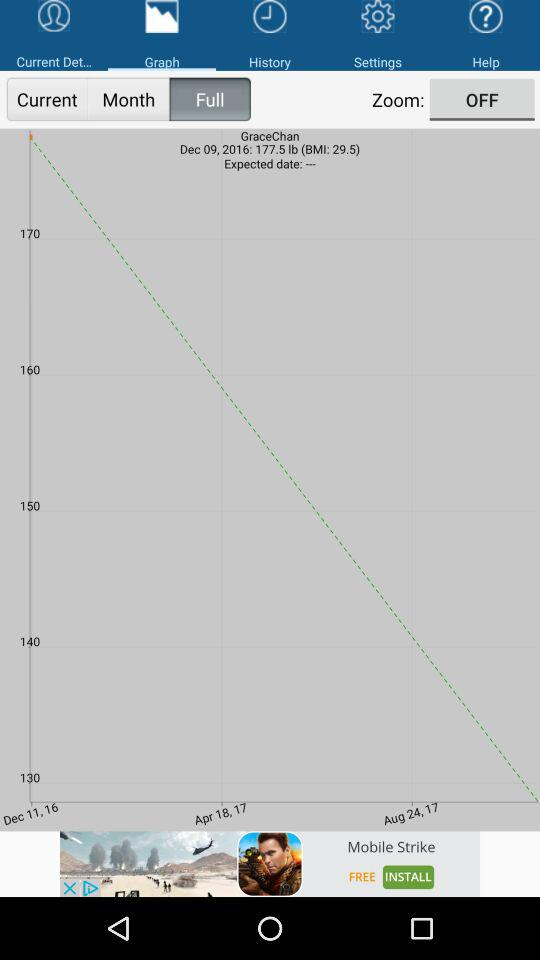On which date was the graph updated? The graph was updated on December 9, 2016. 